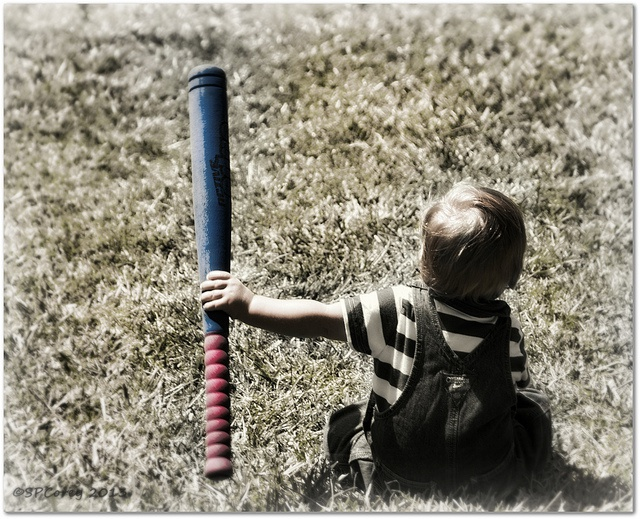Describe the objects in this image and their specific colors. I can see people in white, black, ivory, gray, and darkgray tones and baseball bat in white, black, darkgray, blue, and navy tones in this image. 